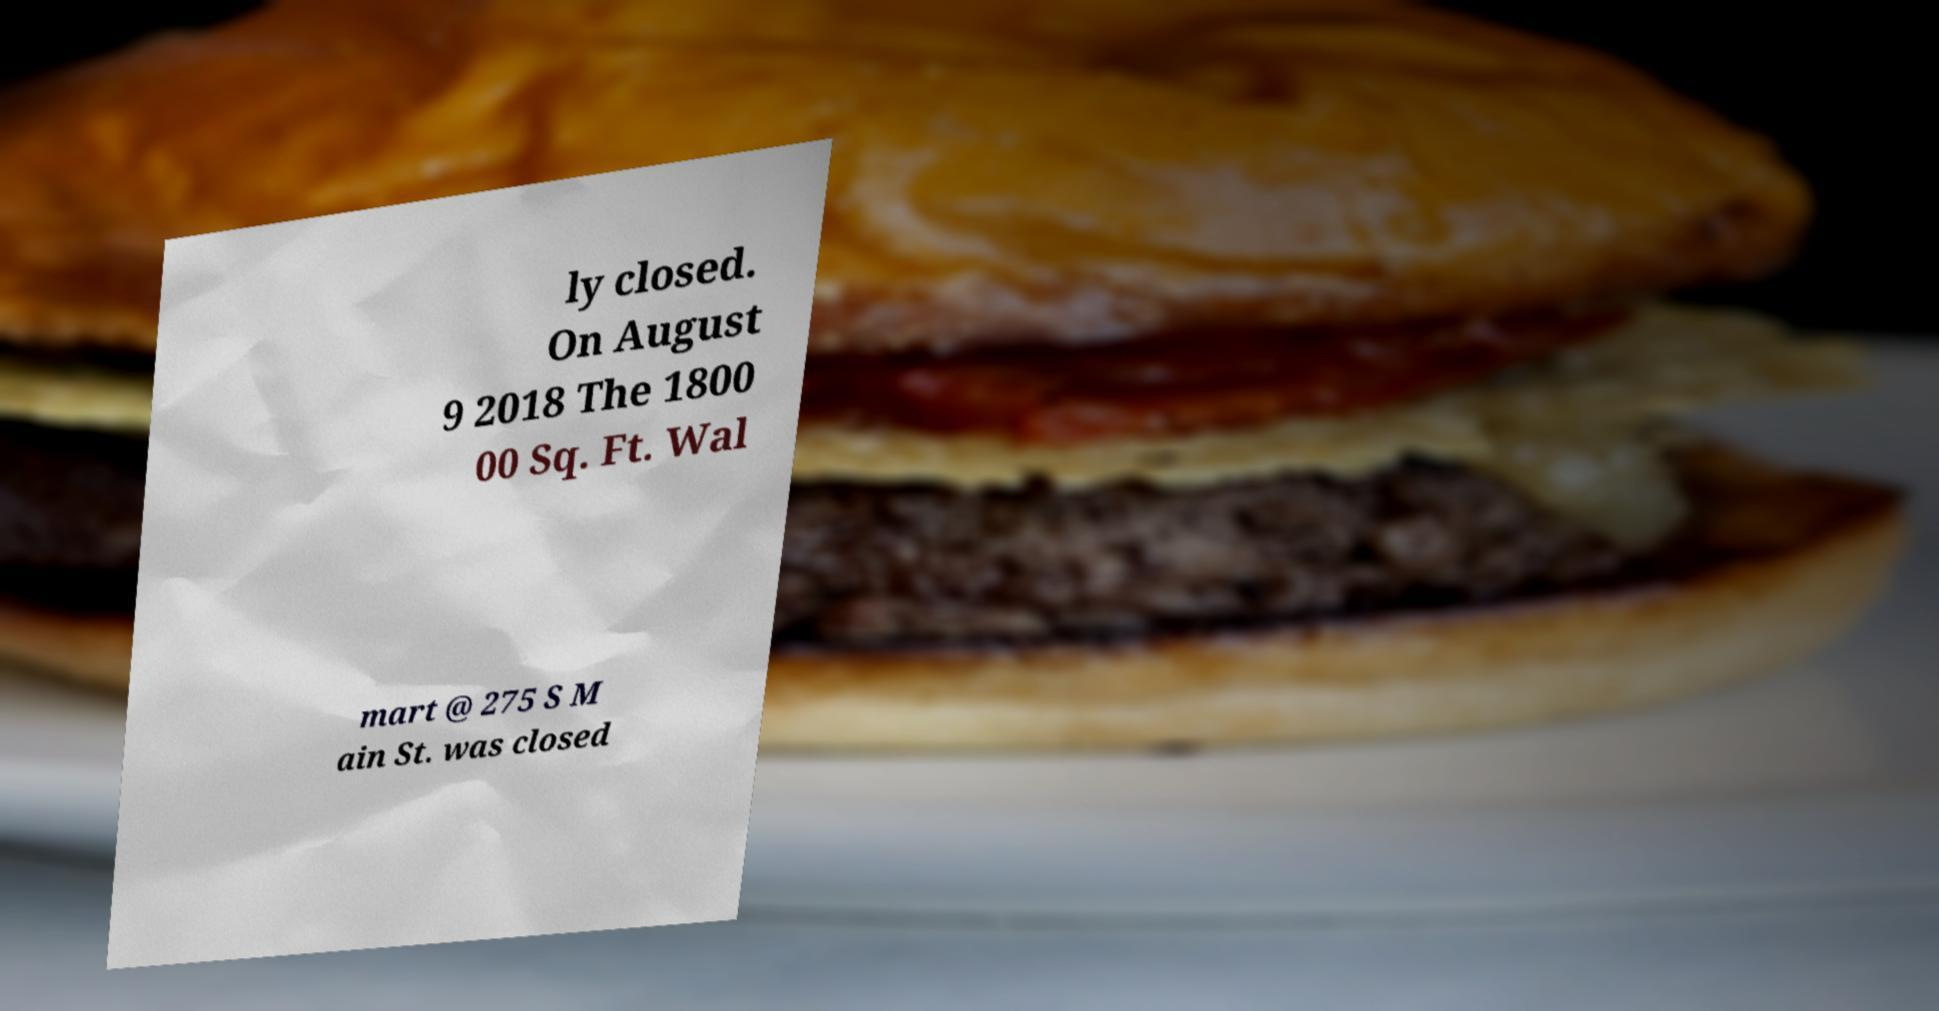Could you extract and type out the text from this image? ly closed. On August 9 2018 The 1800 00 Sq. Ft. Wal mart @ 275 S M ain St. was closed 